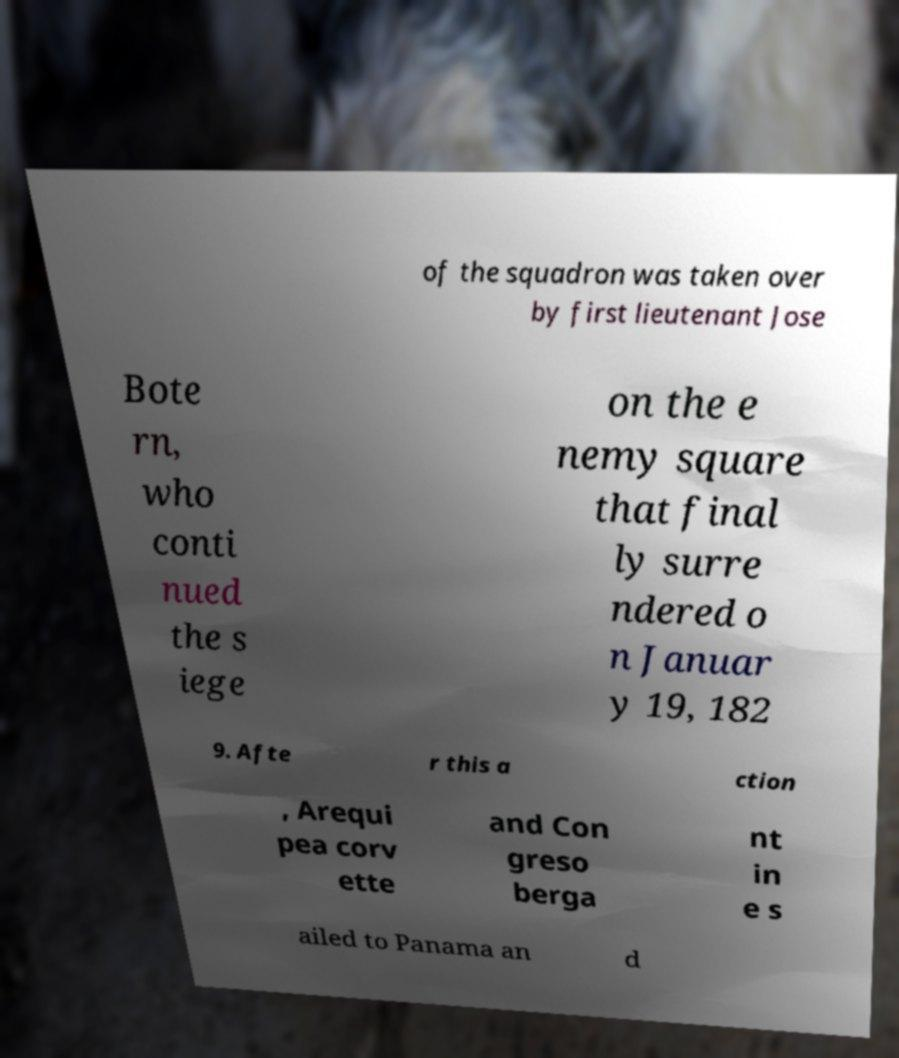Could you assist in decoding the text presented in this image and type it out clearly? of the squadron was taken over by first lieutenant Jose Bote rn, who conti nued the s iege on the e nemy square that final ly surre ndered o n Januar y 19, 182 9. Afte r this a ction , Arequi pea corv ette and Con greso berga nt in e s ailed to Panama an d 